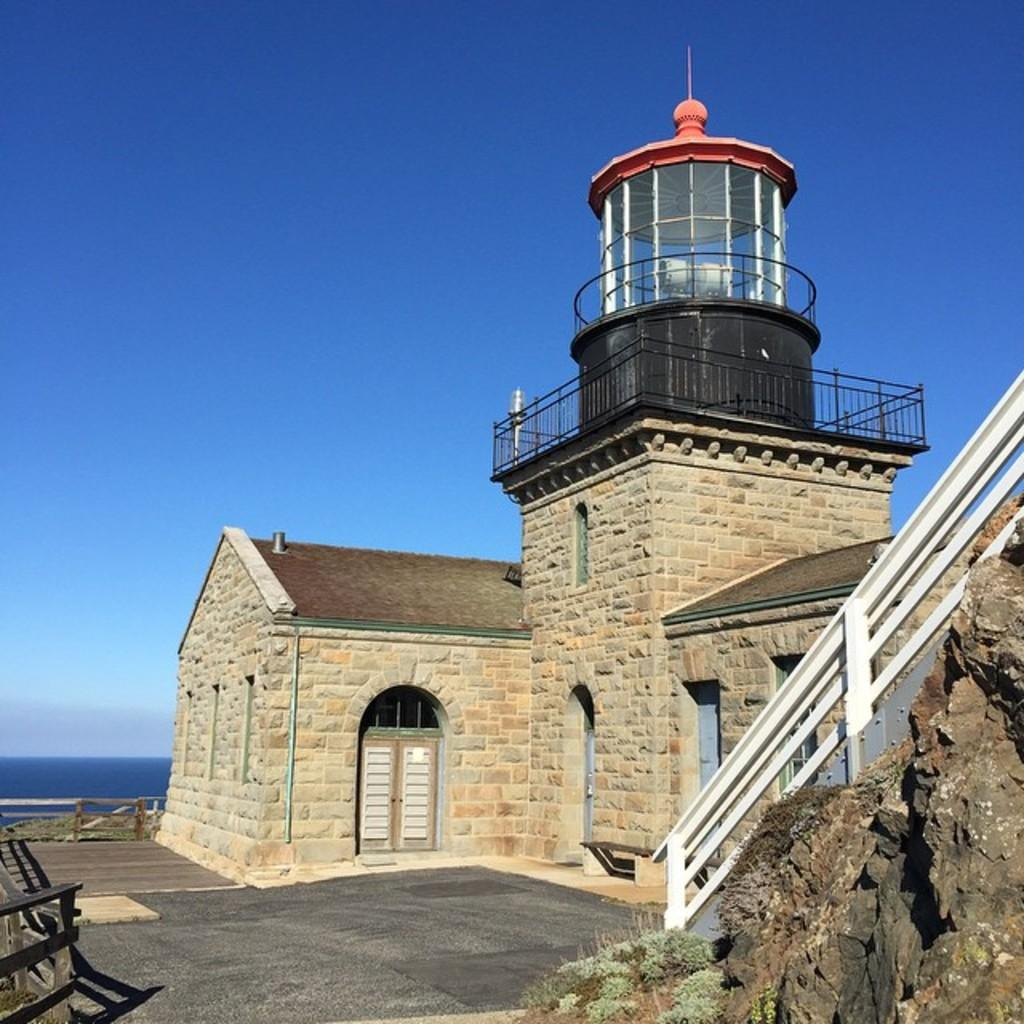What type of structure is present in the image? There is a building in the image. What features can be observed on the building? The building has a roof, windows, and a door. Are there any architectural elements in the image? Yes, there are stairs in the image. What else can be seen in the image besides the building? There are plants and a water body visible in the image. What is the condition of the sky in the image? The sky appears cloudy in the image. What type of arithmetic problem is being solved on the roof of the building in the image? There is no arithmetic problem visible in the image; it only shows a building with a roof, windows, and a door. What kind of animal can be seen interacting with the plants in the image? There are no animals present in the image; it only shows plants and a water body. 